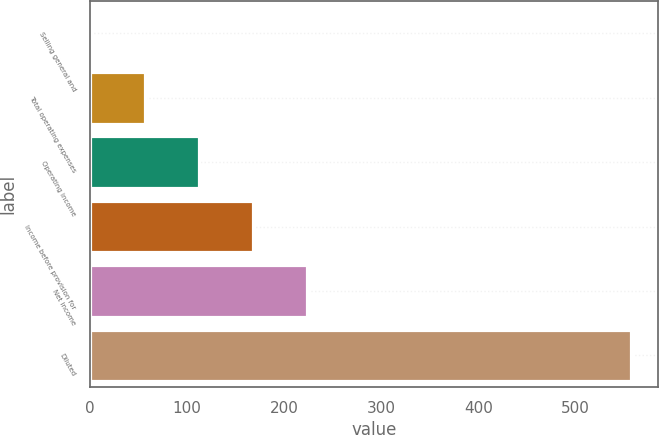Convert chart to OTSL. <chart><loc_0><loc_0><loc_500><loc_500><bar_chart><fcel>Selling general and<fcel>Total operating expenses<fcel>Operating income<fcel>Income before provision for<fcel>Net income<fcel>Diluted<nl><fcel>1<fcel>56.6<fcel>112.2<fcel>167.8<fcel>223.4<fcel>557<nl></chart> 